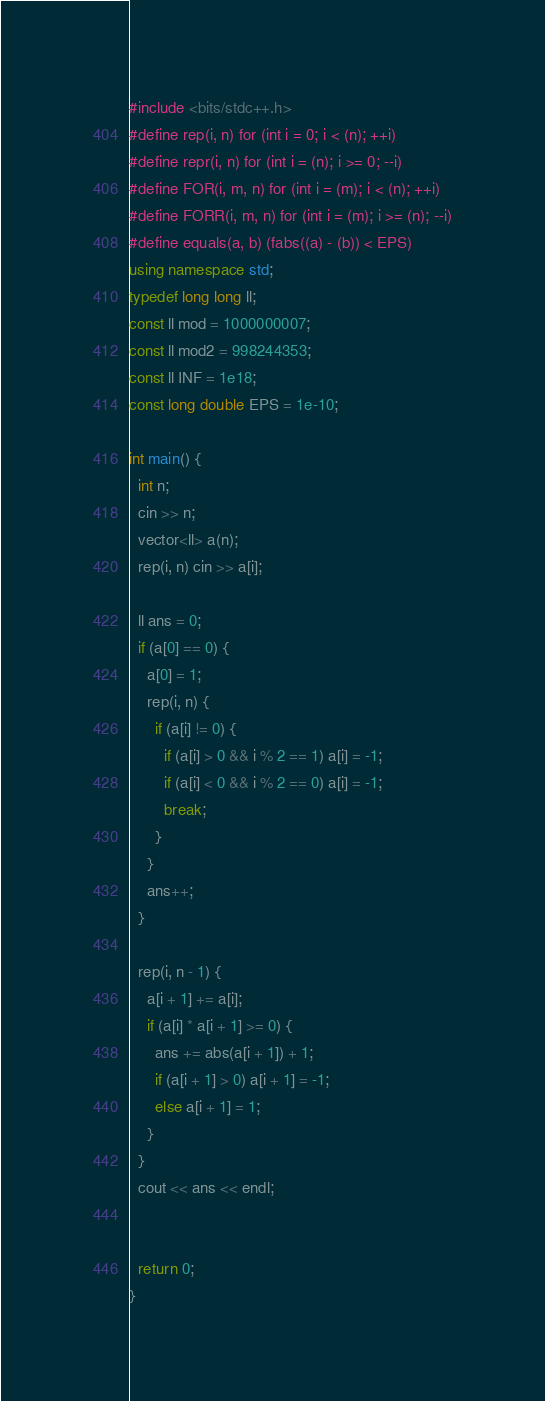<code> <loc_0><loc_0><loc_500><loc_500><_C++_>#include <bits/stdc++.h>
#define rep(i, n) for (int i = 0; i < (n); ++i)
#define repr(i, n) for (int i = (n); i >= 0; --i)
#define FOR(i, m, n) for (int i = (m); i < (n); ++i)
#define FORR(i, m, n) for (int i = (m); i >= (n); --i)
#define equals(a, b) (fabs((a) - (b)) < EPS)
using namespace std;
typedef long long ll;
const ll mod = 1000000007;
const ll mod2 = 998244353;
const ll INF = 1e18;
const long double EPS = 1e-10;

int main() {
  int n;
  cin >> n;
  vector<ll> a(n);
  rep(i, n) cin >> a[i];

  ll ans = 0;
  if (a[0] == 0) {
    a[0] = 1;
    rep(i, n) {
      if (a[i] != 0) {
        if (a[i] > 0 && i % 2 == 1) a[i] = -1;
        if (a[i] < 0 && i % 2 == 0) a[i] = -1;
        break;
      }
    }
    ans++;
  }

  rep(i, n - 1) {
    a[i + 1] += a[i];
    if (a[i] * a[i + 1] >= 0) {
      ans += abs(a[i + 1]) + 1;
      if (a[i + 1] > 0) a[i + 1] = -1;
      else a[i + 1] = 1;
    }
  }
  cout << ans << endl;

  
  return 0;
}

</code> 